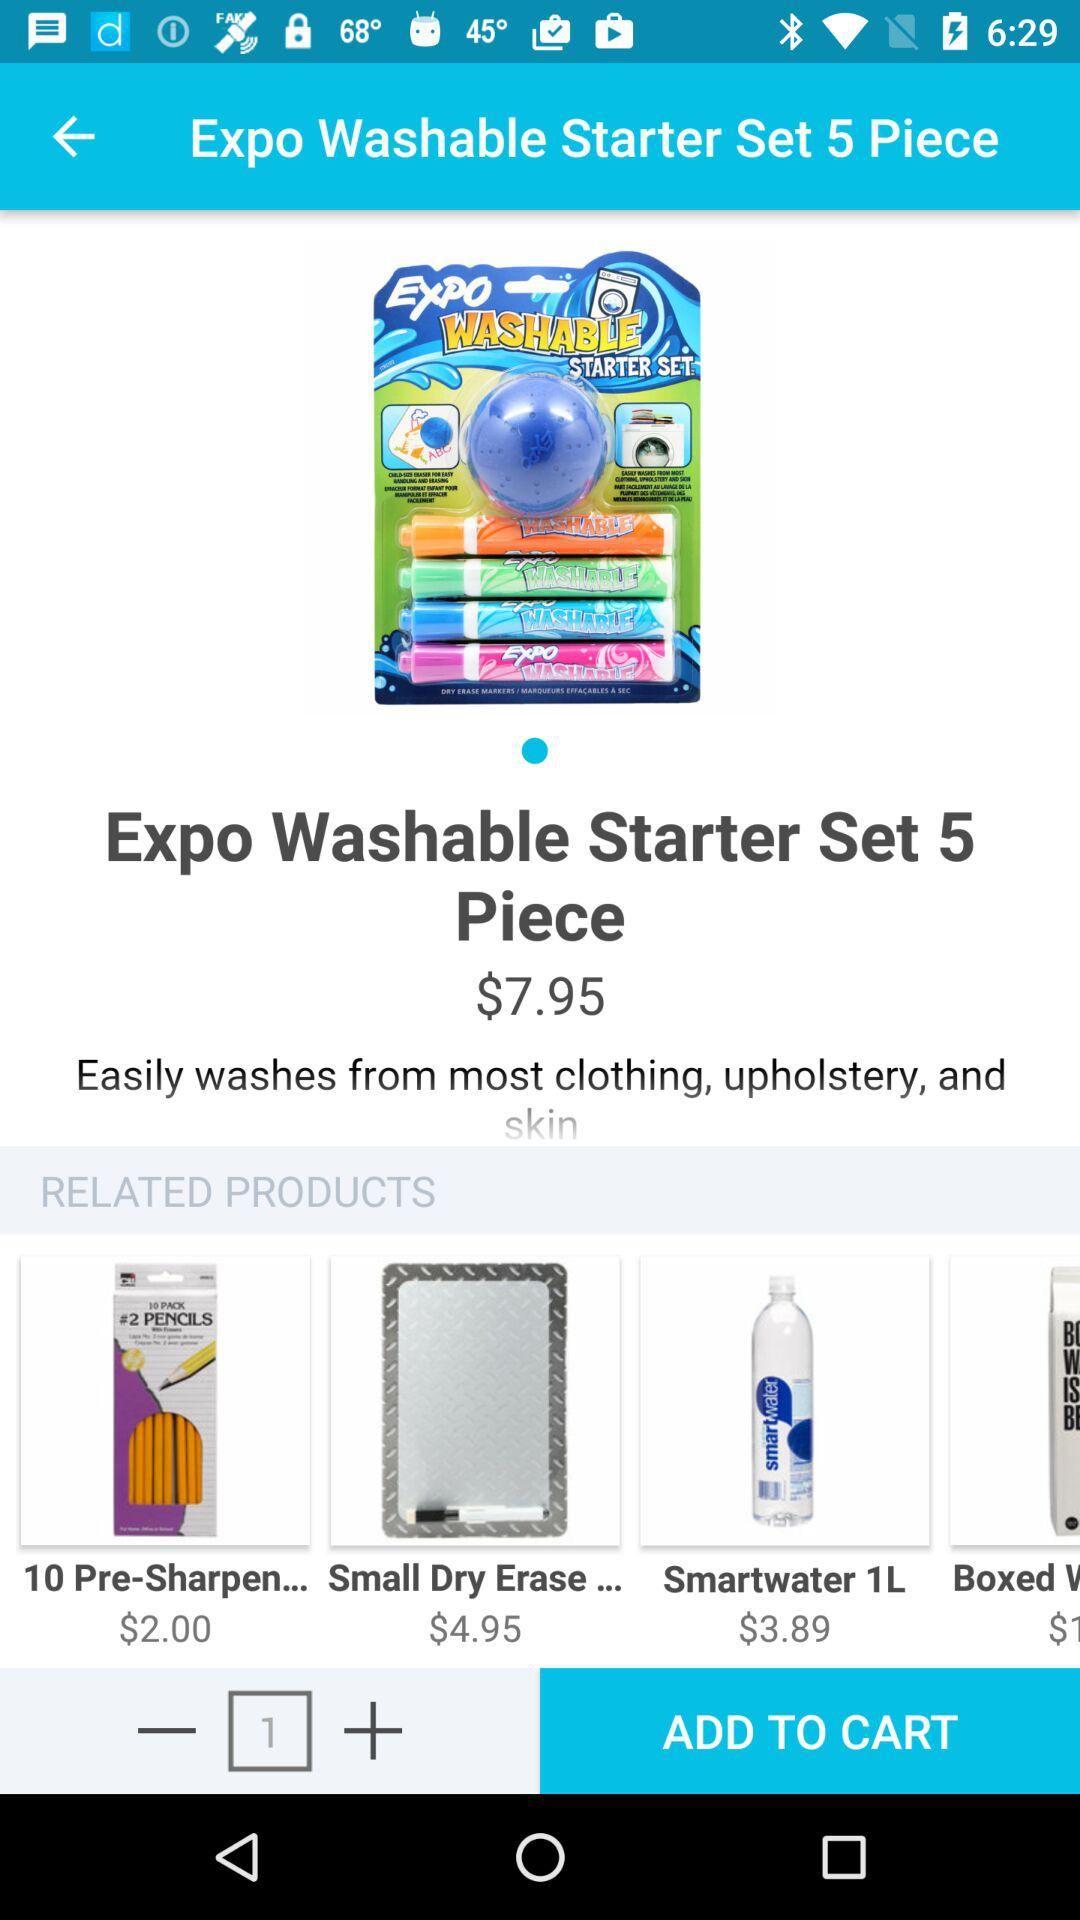What is the price of "Smartwater 1L"? The price of "Smartwater 1L" is $3.89. 